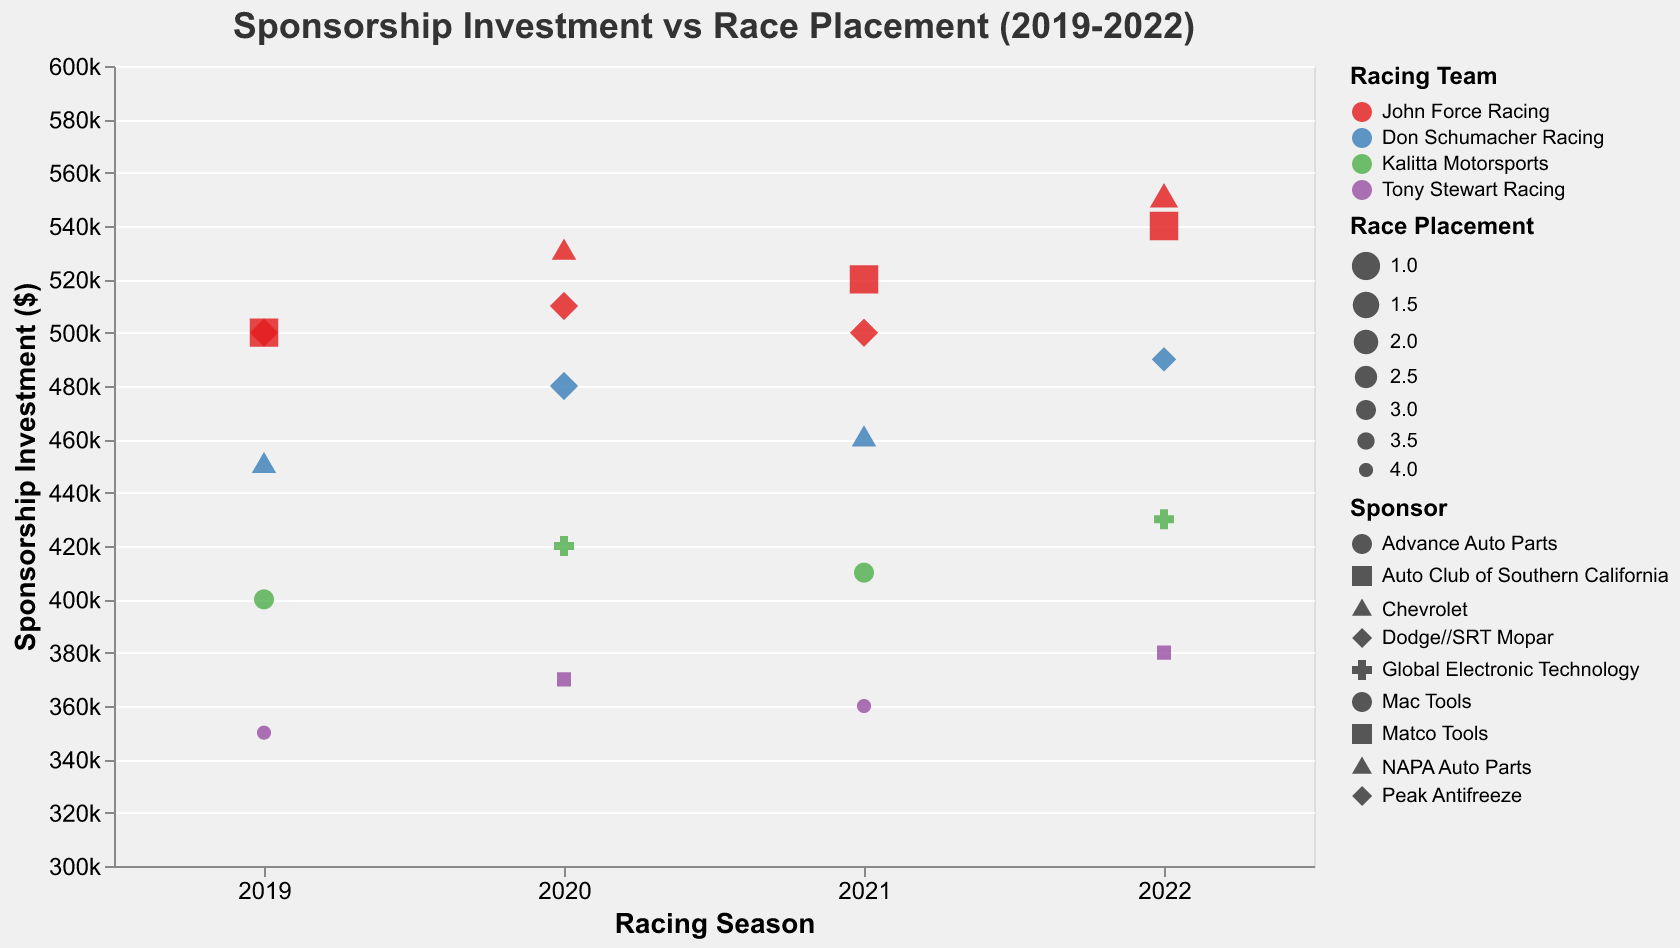How does sponsorship investment in 2019 compare to 2022? To find this out, compare the "Sponsorship Investment" values for data points labeled 2019 with those labeled 2022. By observing the plot, we can see that investments in 2022 (ranging between $380,000 and $550,000) are generally higher than in 2019 (ranging between $350,000 and $500,000).
Answer: Investments in 2022 are generally higher than in 2019 Which team had the highest sponsorship investment in 2022? Look at the plot points labeled 2022 and check which team's points are highest on the "Sponsorship Investment" axis. The highest value in 2022 is $550,000 for John Force Racing with the Chevrolet sponsorship.
Answer: John Force Racing What is the relationship between sponsorship investment and race placement? By observing the size and position of points, we can see that larger points (indicating better placement) tend to appear higher on the y-axis (indicating higher investment). Thus, higher investment generally corresponds to a better race placement.
Answer: Higher investment generally results in better placement How did Don Schumacher Racing perform across all seasons and sponsors? Look at the plot points for Don Schumacher Racing across all years. The placements noted by the size of the points range from 1st place to 2nd place. Investments range from $450,000 to $490,000. The performance is consistently high across seasons.
Answer: Consistently high, 1st and 2nd places Which sponsor had the highest investment across all seasons? Check the tooltip in the figure for the highest investment value when hovering over each point and note the sponsor. The highest investment noted is $550,000 by Chevrolet in 2022.
Answer: Chevrolet Which year had the highest average sponsorship investment? To find this, calculate the average investment for each year by summing all investment values for that year and dividing by the number of data points. Observing the plot: 
- 2019: (500000 + 450000 + 400000 + 350000 + 500000) / 5 = 440000
- 2020: (480000 + 420000 + 530000 + 370000 + 510000) / 5 = 462000
- 2021: (460000 + 410000 + 360000 + 520000 + 500000) / 5 = 450000
- 2022: (490000 + 430000 + 550000 + 380000 + 540000) / 5 = 478000 
So, the year with the highest average investment is 2022.
Answer: 2022 How does the team's performance change from 2020 to 2021 for Kalitta Motorsports? Kalitta Motorsports' performance (noted by placement size) stays the same from 2020 to 2021 as both years show a placement of 3rd place. Their investment also follows a similar level of around $420,000 to $410,000.
Answer: Performance stays the same at 3rd place What is the difference in sponsorship investments between the highest and the lowest values in 2020? Identify the highest and lowest points for the year 2020 in terms of investment. The highest is John Force Racing with Chevrolet at $530,000 and the lowest is Tony Stewart Racing with Matco Tools at $370,000. The difference is $530,000 - $370,000 = $160,000.
Answer: $160,000 